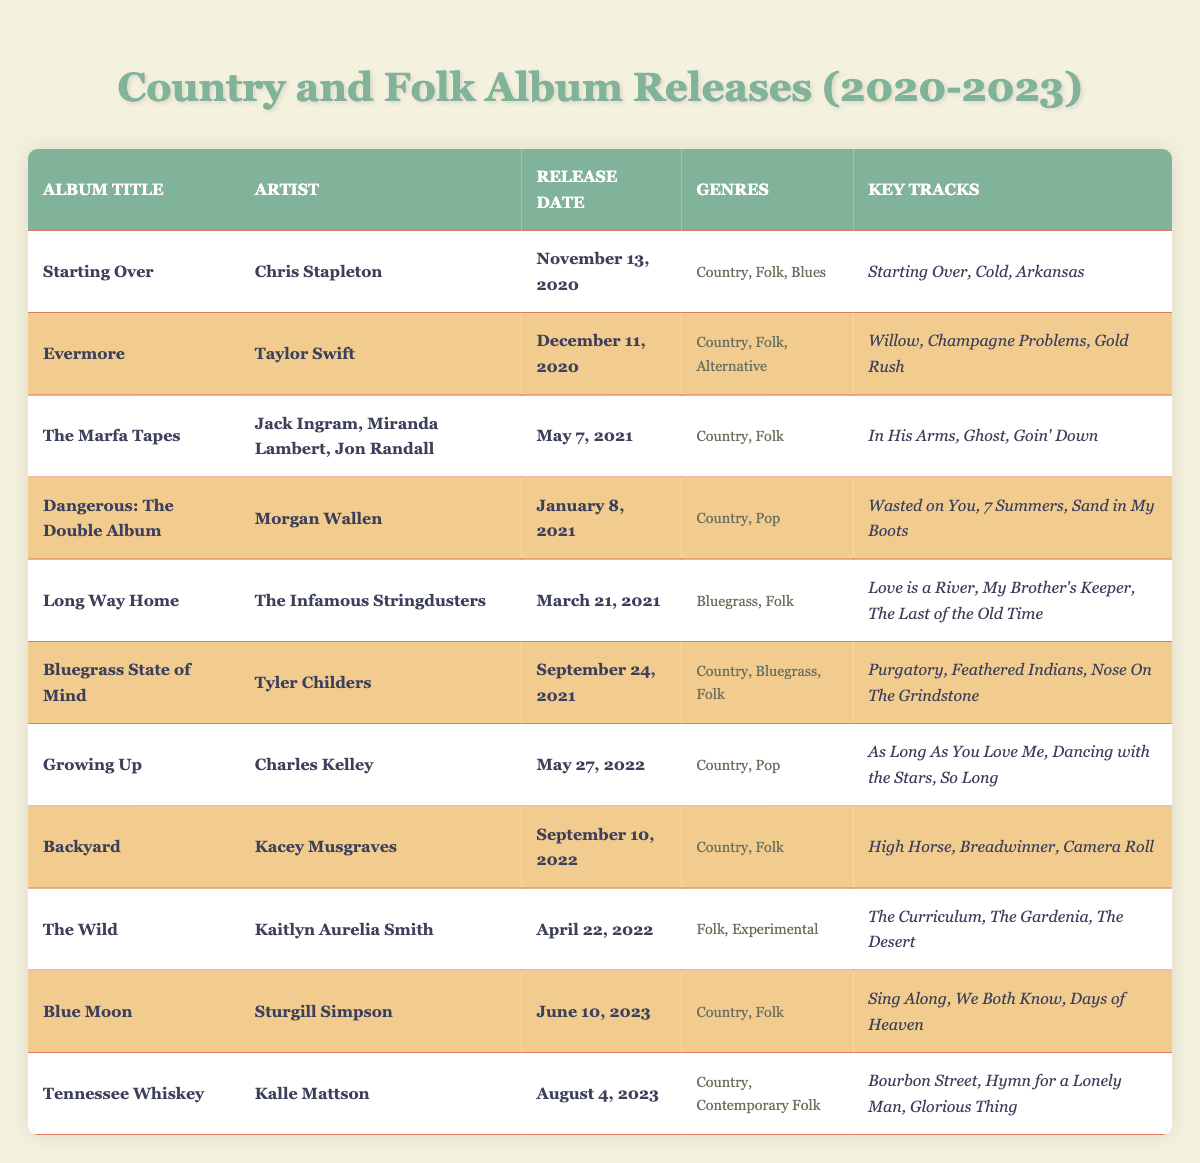What is the release date of "Bluegrass State of Mind"? The table shows the release date for "Bluegrass State of Mind" is listed directly in the respective row under the "Release Date" column.
Answer: September 24, 2021 Who is the artist of the album "Evermore"? The table contains the artist's name in the row for "Evermore," which is under the "Artist" column.
Answer: Taylor Swift How many albums were released in the year 2021? By examining the table, the albums released in 2021 are "The Marfa Tapes," "Dangerous: The Double Album," "Long Way Home," and "Bluegrass State of Mind," making a total of four albums.
Answer: 4 Is "Kacey Musgraves" associated with any albums in the table? The table indicates that Kacey Musgraves is listed as an artist for the album "Backyard." Therefore, the statement is true.
Answer: Yes Which album has the most genres listed? By inspecting the genre columns, "Evermore" lists three genres: Country, Folk, and Alternative, which is more than any other album.
Answer: Evermore Which album was released the earliest among the listed? The release dates of the albums are compared, and "Starting Over" is found to have the earliest date of November 13, 2020.
Answer: Starting Over Are there any albums solely categorized as "Folk"? After reviewing the genres of each album, "The Wild," classified under Folk and Experimental, doesn't strictly mean it is solely Folk, thus there are no albums listed only as "Folk."
Answer: No Which album features "High Horse" as a key track? The table shows that "High Horse" is listed as a key track under the album "Backyard."
Answer: Backyard What is the genre classification of the album "Growing Up"? The genre(s) for "Growing Up" is provided in the genre section, which lists it under Country and Pop.
Answer: Country, Pop Which artist has the latest album release according to the table? Looking at the release dates, "Tennessee Whiskey" by Kalle Mattson, released on August 4, 2023, is the most recent.
Answer: Kalle Mattson What are the key tracks for "The Marfa Tapes"? The table lists the key tracks for "The Marfa Tapes" under the key tracks column, which includes "In His Arms," "Ghost," and "Goin' Down."
Answer: In His Arms, Ghost, Goin' Down 